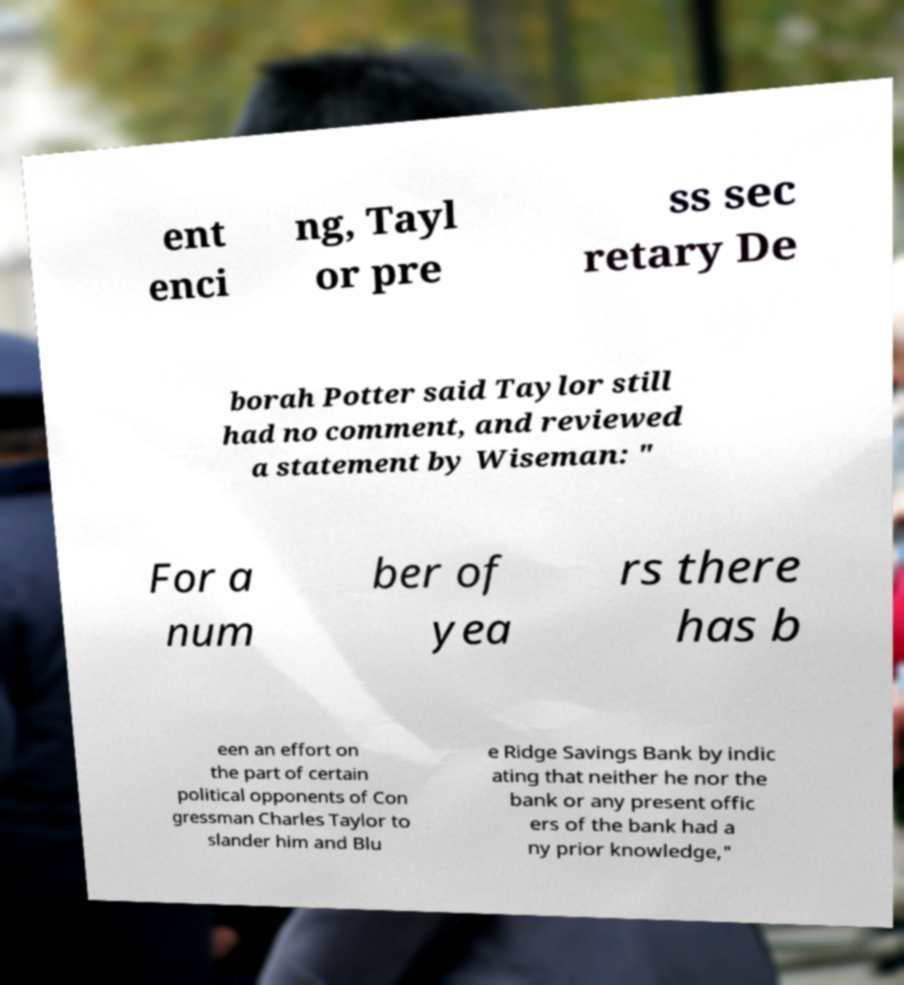Can you read and provide the text displayed in the image?This photo seems to have some interesting text. Can you extract and type it out for me? ent enci ng, Tayl or pre ss sec retary De borah Potter said Taylor still had no comment, and reviewed a statement by Wiseman: " For a num ber of yea rs there has b een an effort on the part of certain political opponents of Con gressman Charles Taylor to slander him and Blu e Ridge Savings Bank by indic ating that neither he nor the bank or any present offic ers of the bank had a ny prior knowledge," 